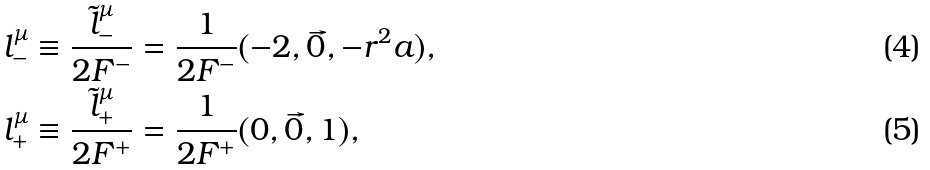Convert formula to latex. <formula><loc_0><loc_0><loc_500><loc_500>l _ { - } ^ { \mu } \equiv \frac { \tilde { l } _ { - } ^ { \mu } } { 2 F ^ { - } } & = \frac { 1 } { 2 F ^ { - } } ( - 2 , \vec { 0 } , - r ^ { 2 } a ) , \\ l _ { + } ^ { \mu } \equiv \frac { \tilde { l } _ { + } ^ { \mu } } { 2 F ^ { + } } & = \frac { 1 } { 2 F ^ { + } } ( 0 , \vec { 0 } , 1 ) ,</formula> 